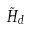<formula> <loc_0><loc_0><loc_500><loc_500>\tilde { H } _ { d }</formula> 